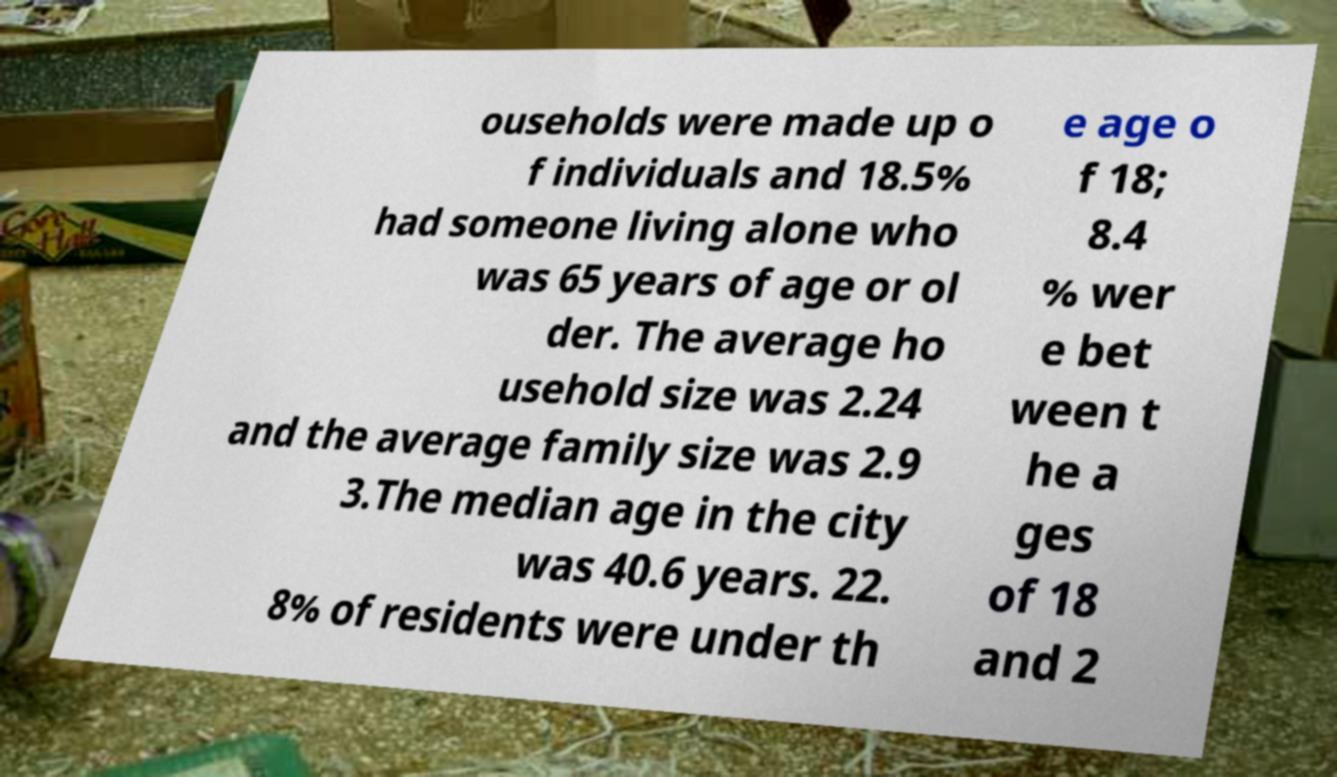Could you assist in decoding the text presented in this image and type it out clearly? ouseholds were made up o f individuals and 18.5% had someone living alone who was 65 years of age or ol der. The average ho usehold size was 2.24 and the average family size was 2.9 3.The median age in the city was 40.6 years. 22. 8% of residents were under th e age o f 18; 8.4 % wer e bet ween t he a ges of 18 and 2 